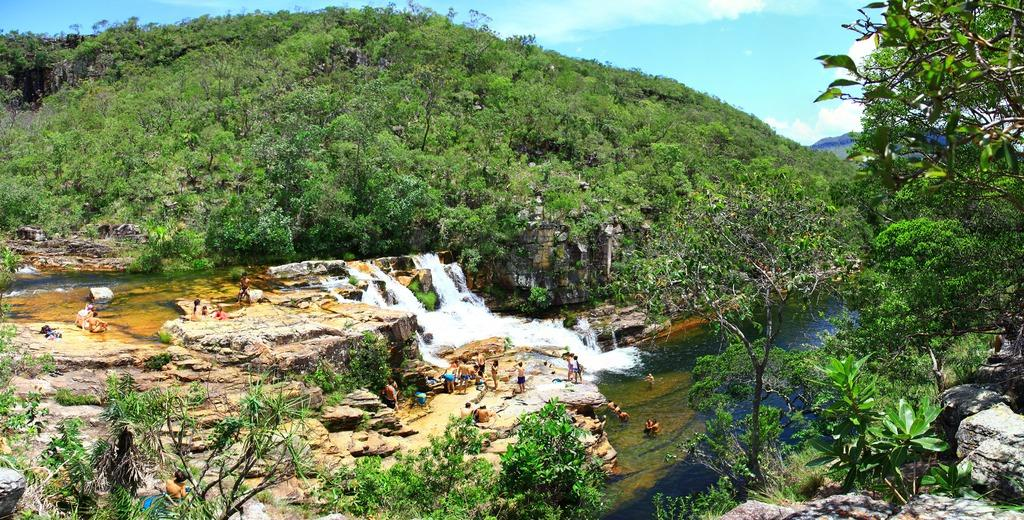What is happening in the image involving a liquid? Water is flowing in the image. What are the people in the image doing? Some people are standing, some are seated on rocks, and some are swimming in the water. What type of vegetation can be seen in the image? Trees are visible in the image. How would you describe the sky in the image? The sky is blue and cloudy in the image. What type of apple can be seen floating in the water in the image? There is no apple present in the image; it features water flowing and people engaging in various activities. What is being served for lunch in the image? There is no mention of lunch or any food being served in the image. 